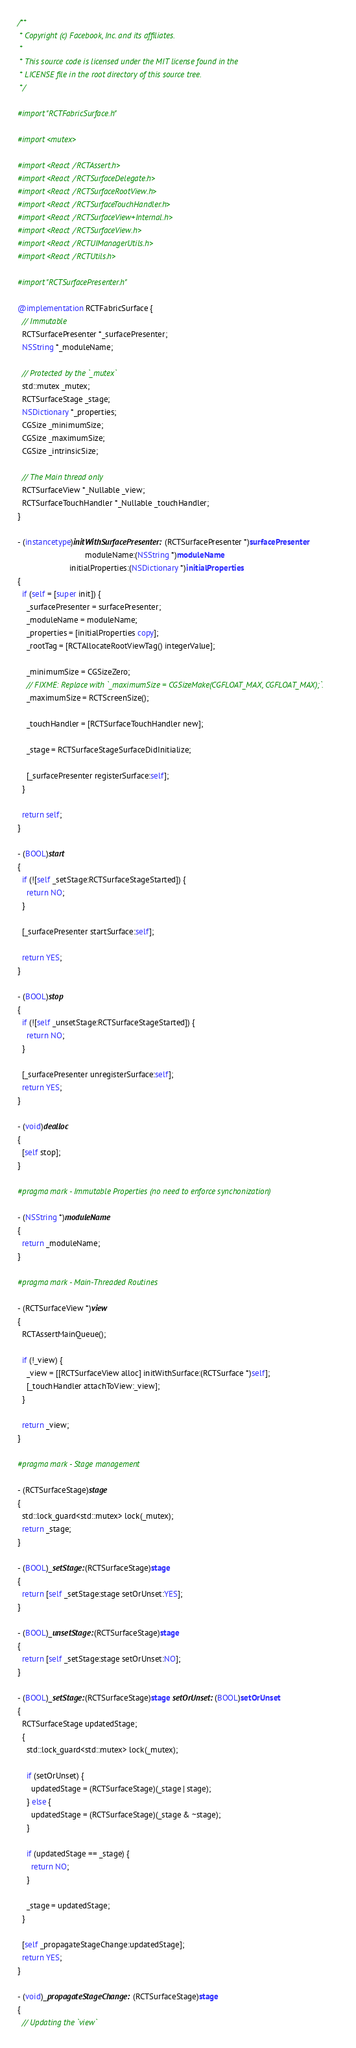<code> <loc_0><loc_0><loc_500><loc_500><_ObjectiveC_>/**
 * Copyright (c) Facebook, Inc. and its affiliates.
 *
 * This source code is licensed under the MIT license found in the
 * LICENSE file in the root directory of this source tree.
 */

#import "RCTFabricSurface.h"

#import <mutex>

#import <React/RCTAssert.h>
#import <React/RCTSurfaceDelegate.h>
#import <React/RCTSurfaceRootView.h>
#import <React/RCTSurfaceTouchHandler.h>
#import <React/RCTSurfaceView+Internal.h>
#import <React/RCTSurfaceView.h>
#import <React/RCTUIManagerUtils.h>
#import <React/RCTUtils.h>

#import "RCTSurfacePresenter.h"

@implementation RCTFabricSurface {
  // Immutable
  RCTSurfacePresenter *_surfacePresenter;
  NSString *_moduleName;

  // Protected by the `_mutex`
  std::mutex _mutex;
  RCTSurfaceStage _stage;
  NSDictionary *_properties;
  CGSize _minimumSize;
  CGSize _maximumSize;
  CGSize _intrinsicSize;

  // The Main thread only
  RCTSurfaceView *_Nullable _view;
  RCTSurfaceTouchHandler *_Nullable _touchHandler;
}

- (instancetype)initWithSurfacePresenter:(RCTSurfacePresenter *)surfacePresenter
                              moduleName:(NSString *)moduleName
                       initialProperties:(NSDictionary *)initialProperties
{
  if (self = [super init]) {
    _surfacePresenter = surfacePresenter;
    _moduleName = moduleName;
    _properties = [initialProperties copy];
    _rootTag = [RCTAllocateRootViewTag() integerValue];

    _minimumSize = CGSizeZero;
    // FIXME: Replace with `_maximumSize = CGSizeMake(CGFLOAT_MAX, CGFLOAT_MAX);`.
    _maximumSize = RCTScreenSize();

    _touchHandler = [RCTSurfaceTouchHandler new];

    _stage = RCTSurfaceStageSurfaceDidInitialize;

    [_surfacePresenter registerSurface:self];
  }

  return self;
}

- (BOOL)start
{
  if (![self _setStage:RCTSurfaceStageStarted]) {
    return NO;
  }

  [_surfacePresenter startSurface:self];

  return YES;
}

- (BOOL)stop
{
  if (![self _unsetStage:RCTSurfaceStageStarted]) {
    return NO;
  }

  [_surfacePresenter unregisterSurface:self];
  return YES;
}

- (void)dealloc
{
  [self stop];
}

#pragma mark - Immutable Properties (no need to enforce synchonization)

- (NSString *)moduleName
{
  return _moduleName;
}

#pragma mark - Main-Threaded Routines

- (RCTSurfaceView *)view
{
  RCTAssertMainQueue();

  if (!_view) {
    _view = [[RCTSurfaceView alloc] initWithSurface:(RCTSurface *)self];
    [_touchHandler attachToView:_view];
  }

  return _view;
}

#pragma mark - Stage management

- (RCTSurfaceStage)stage
{
  std::lock_guard<std::mutex> lock(_mutex);
  return _stage;
}

- (BOOL)_setStage:(RCTSurfaceStage)stage
{
  return [self _setStage:stage setOrUnset:YES];
}

- (BOOL)_unsetStage:(RCTSurfaceStage)stage
{
  return [self _setStage:stage setOrUnset:NO];
}

- (BOOL)_setStage:(RCTSurfaceStage)stage setOrUnset:(BOOL)setOrUnset
{
  RCTSurfaceStage updatedStage;
  {
    std::lock_guard<std::mutex> lock(_mutex);

    if (setOrUnset) {
      updatedStage = (RCTSurfaceStage)(_stage | stage);
    } else {
      updatedStage = (RCTSurfaceStage)(_stage & ~stage);
    }

    if (updatedStage == _stage) {
      return NO;
    }

    _stage = updatedStage;
  }

  [self _propagateStageChange:updatedStage];
  return YES;
}

- (void)_propagateStageChange:(RCTSurfaceStage)stage
{
  // Updating the `view`</code> 